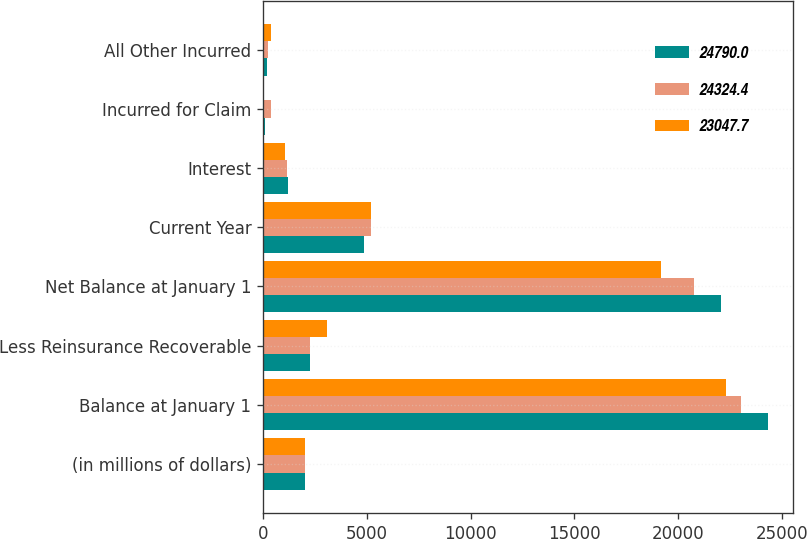<chart> <loc_0><loc_0><loc_500><loc_500><stacked_bar_chart><ecel><fcel>(in millions of dollars)<fcel>Balance at January 1<fcel>Less Reinsurance Recoverable<fcel>Net Balance at January 1<fcel>Current Year<fcel>Interest<fcel>Incurred for Claim<fcel>All Other Incurred<nl><fcel>24790<fcel>2007<fcel>24324.4<fcel>2257.3<fcel>22067.1<fcel>4836.9<fcel>1199.9<fcel>65.8<fcel>174.3<nl><fcel>24324.4<fcel>2006<fcel>23047.7<fcel>2267.3<fcel>20780.4<fcel>5204.4<fcel>1149.5<fcel>396.4<fcel>228.5<nl><fcel>23047.7<fcel>2005<fcel>22285.1<fcel>3096.2<fcel>19188.9<fcel>5188.3<fcel>1066.9<fcel>52.7<fcel>390.2<nl></chart> 